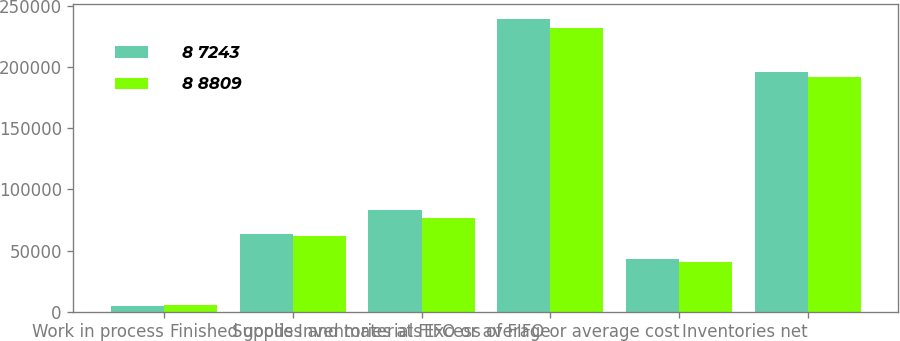<chart> <loc_0><loc_0><loc_500><loc_500><stacked_bar_chart><ecel><fcel>Work in process<fcel>Finished goods<fcel>Supplies and materials<fcel>Inventories at FIFO or average<fcel>Excess of FIFO or average cost<fcel>Inventories net<nl><fcel>8 7243<fcel>5021<fcel>63633<fcel>83431<fcel>239328<fcel>43382<fcel>195946<nl><fcel>8 8809<fcel>5119<fcel>61994<fcel>76197<fcel>232119<fcel>40291<fcel>191828<nl></chart> 